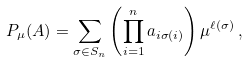Convert formula to latex. <formula><loc_0><loc_0><loc_500><loc_500>P _ { \mu } ( A ) = \sum _ { \sigma \in S _ { n } } \left ( \prod _ { i = 1 } ^ { n } a _ { i \sigma ( i ) } \right ) \mu ^ { \ell ( \sigma ) } \, ,</formula> 